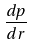<formula> <loc_0><loc_0><loc_500><loc_500>\frac { d p } { d r }</formula> 